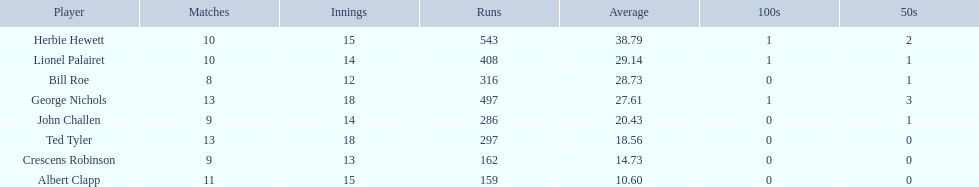Identify a player with an average exceeding 2 Herbie Hewett. 